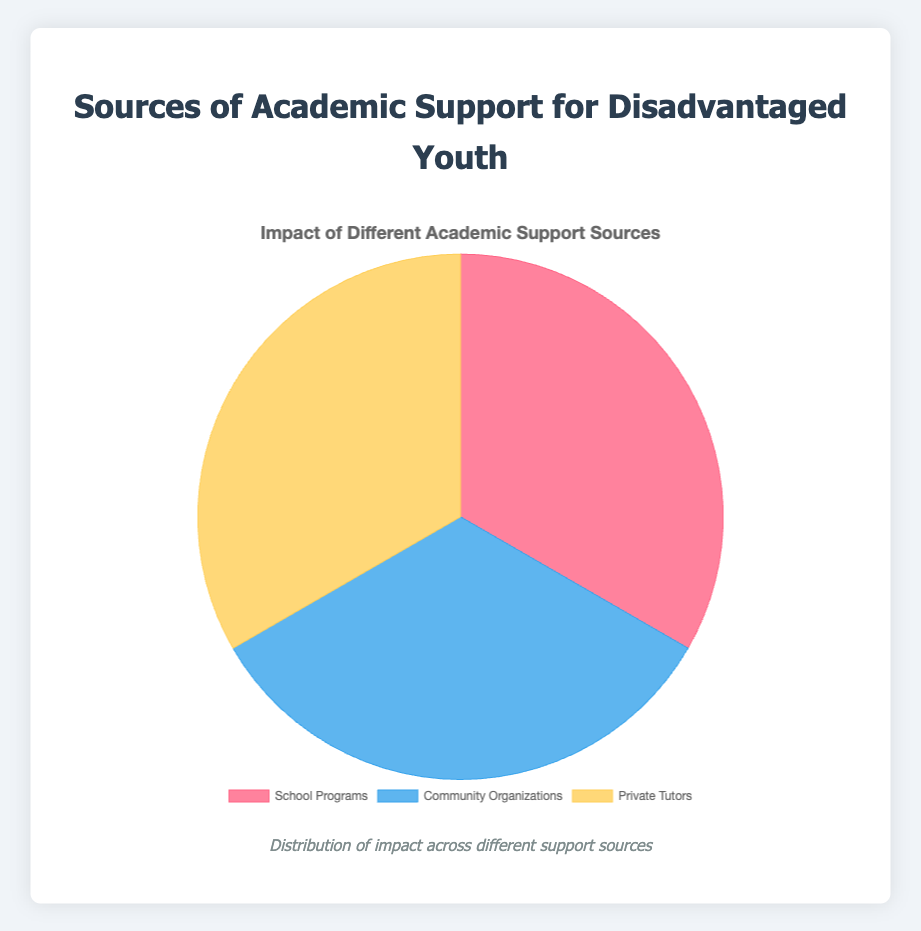what are the three categories of academic support for disadvantaged youth mentioned in the chart? The chart shows three sources of academic support: School Programs, Community Organizations, and Private Tutors, represented by three segments in the pie chart.
Answer: School Programs, Community Organizations, Private Tutors Which source of academic support has the largest impact on disadvantaged youth? By looking at the size of the pie chart segments, we can identify which category has the largest area representing a higher impact.
Answer: Private Tutors Among the different sources, which one has the smallest impact on disadvantaged youth? The smallest segment in the pie chart corresponds to the source with the least impact, which can be visually identified.
Answer: School Programs Compare the impact of Community Organizations and School Programs. Which one shows a higher impact? Comparing the size of the segments representing Community Organizations and School Programs, the larger segment shows a higher impact.
Answer: Community Organizations If you combine the impacts of Community Organizations and School Programs, how does their total impact compare to that of Private Tutors? Summing the impacts of Community Organizations and School Programs, and comparing it to the Private Tutors segment will help determine if their combined impact is greater or less.
Answer: Combined impact is greater What percentage of the pie chart is represented by Community Organizations? Visually, the pie chart is divided into three segments, with each color corresponding to a source. The portion labeled for Community Organizations is visually estimated to determine its percentage of the whole pie.
Answer: 33.33% How do the visual attributes (color) differ among the three sources of academic support? The pie chart uses different colors for each segment representing various support sources. Observing these colors helps distinguish each source.
Answer: Red for School Programs, Blue for Community Organizations, Yellow for Private Tutors Rank the sources of academic support from largest to smallest impact based on the pie chart. By ordering segments from the widest to the narrowest, we can rank the sources in decreasing order of impact.
Answer: Private Tutors, Community Organizations, School Programs Is the impact from School Programs and Private Tutors equal or not? The visual comparison of the segments' sizes for School Programs and Private Tutors helps to determine if they are equal or different.
Answer: Not equal Calculate the difference in impact between Private Tutors and Community Organizations. Subtracting the percentage represented by Community Organizations from that of Private Tutors provides the difference.
Answer: 33.34% 